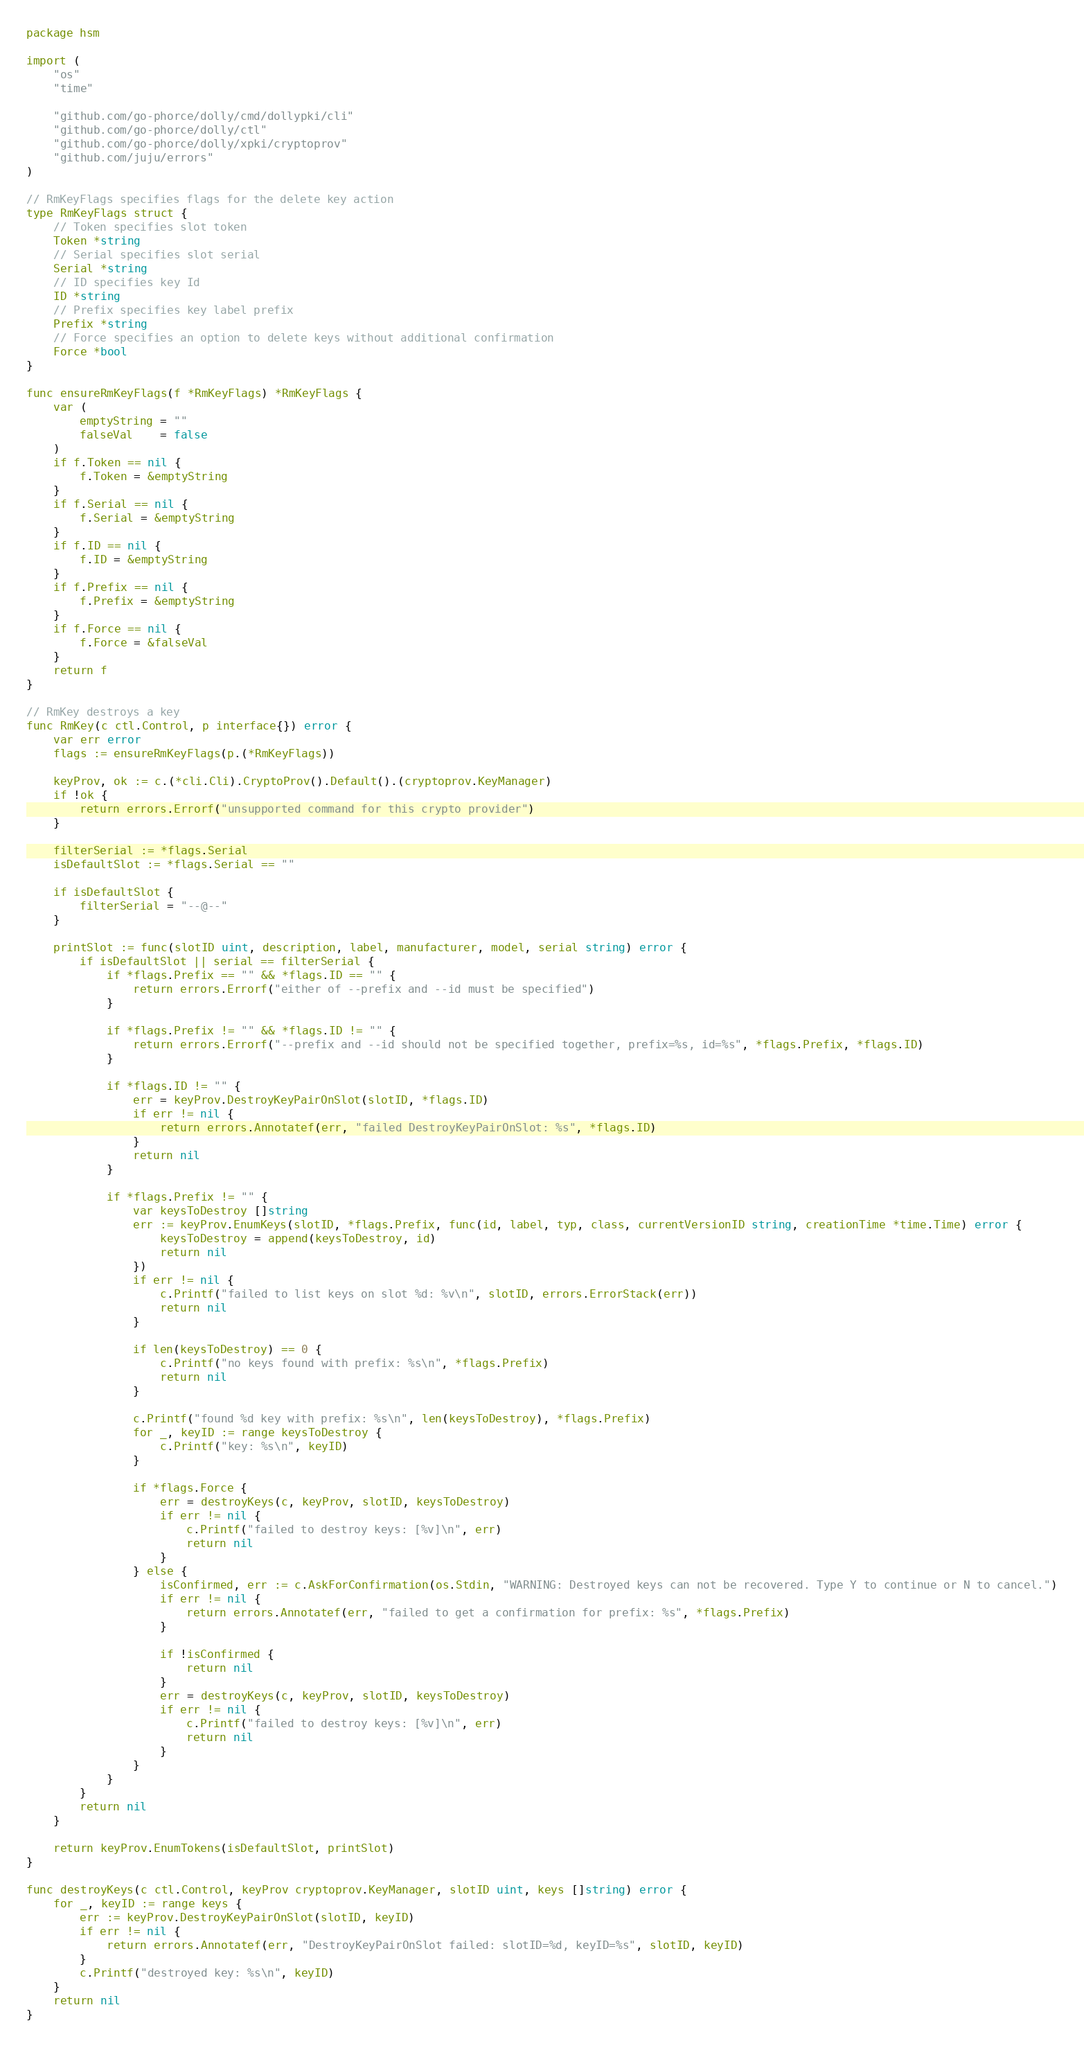Convert code to text. <code><loc_0><loc_0><loc_500><loc_500><_Go_>package hsm

import (
	"os"
	"time"

	"github.com/go-phorce/dolly/cmd/dollypki/cli"
	"github.com/go-phorce/dolly/ctl"
	"github.com/go-phorce/dolly/xpki/cryptoprov"
	"github.com/juju/errors"
)

// RmKeyFlags specifies flags for the delete key action
type RmKeyFlags struct {
	// Token specifies slot token
	Token *string
	// Serial specifies slot serial
	Serial *string
	// ID specifies key Id
	ID *string
	// Prefix specifies key label prefix
	Prefix *string
	// Force specifies an option to delete keys without additional confirmation
	Force *bool
}

func ensureRmKeyFlags(f *RmKeyFlags) *RmKeyFlags {
	var (
		emptyString = ""
		falseVal    = false
	)
	if f.Token == nil {
		f.Token = &emptyString
	}
	if f.Serial == nil {
		f.Serial = &emptyString
	}
	if f.ID == nil {
		f.ID = &emptyString
	}
	if f.Prefix == nil {
		f.Prefix = &emptyString
	}
	if f.Force == nil {
		f.Force = &falseVal
	}
	return f
}

// RmKey destroys a key
func RmKey(c ctl.Control, p interface{}) error {
	var err error
	flags := ensureRmKeyFlags(p.(*RmKeyFlags))

	keyProv, ok := c.(*cli.Cli).CryptoProv().Default().(cryptoprov.KeyManager)
	if !ok {
		return errors.Errorf("unsupported command for this crypto provider")
	}

	filterSerial := *flags.Serial
	isDefaultSlot := *flags.Serial == ""

	if isDefaultSlot {
		filterSerial = "--@--"
	}

	printSlot := func(slotID uint, description, label, manufacturer, model, serial string) error {
		if isDefaultSlot || serial == filterSerial {
			if *flags.Prefix == "" && *flags.ID == "" {
				return errors.Errorf("either of --prefix and --id must be specified")
			}

			if *flags.Prefix != "" && *flags.ID != "" {
				return errors.Errorf("--prefix and --id should not be specified together, prefix=%s, id=%s", *flags.Prefix, *flags.ID)
			}

			if *flags.ID != "" {
				err = keyProv.DestroyKeyPairOnSlot(slotID, *flags.ID)
				if err != nil {
					return errors.Annotatef(err, "failed DestroyKeyPairOnSlot: %s", *flags.ID)
				}
				return nil
			}

			if *flags.Prefix != "" {
				var keysToDestroy []string
				err := keyProv.EnumKeys(slotID, *flags.Prefix, func(id, label, typ, class, currentVersionID string, creationTime *time.Time) error {
					keysToDestroy = append(keysToDestroy, id)
					return nil
				})
				if err != nil {
					c.Printf("failed to list keys on slot %d: %v\n", slotID, errors.ErrorStack(err))
					return nil
				}

				if len(keysToDestroy) == 0 {
					c.Printf("no keys found with prefix: %s\n", *flags.Prefix)
					return nil
				}

				c.Printf("found %d key with prefix: %s\n", len(keysToDestroy), *flags.Prefix)
				for _, keyID := range keysToDestroy {
					c.Printf("key: %s\n", keyID)
				}

				if *flags.Force {
					err = destroyKeys(c, keyProv, slotID, keysToDestroy)
					if err != nil {
						c.Printf("failed to destroy keys: [%v]\n", err)
						return nil
					}
				} else {
					isConfirmed, err := c.AskForConfirmation(os.Stdin, "WARNING: Destroyed keys can not be recovered. Type Y to continue or N to cancel.")
					if err != nil {
						return errors.Annotatef(err, "failed to get a confirmation for prefix: %s", *flags.Prefix)
					}

					if !isConfirmed {
						return nil
					}
					err = destroyKeys(c, keyProv, slotID, keysToDestroy)
					if err != nil {
						c.Printf("failed to destroy keys: [%v]\n", err)
						return nil
					}
				}
			}
		}
		return nil
	}

	return keyProv.EnumTokens(isDefaultSlot, printSlot)
}

func destroyKeys(c ctl.Control, keyProv cryptoprov.KeyManager, slotID uint, keys []string) error {
	for _, keyID := range keys {
		err := keyProv.DestroyKeyPairOnSlot(slotID, keyID)
		if err != nil {
			return errors.Annotatef(err, "DestroyKeyPairOnSlot failed: slotID=%d, keyID=%s", slotID, keyID)
		}
		c.Printf("destroyed key: %s\n", keyID)
	}
	return nil
}
</code> 